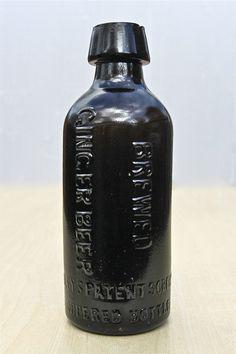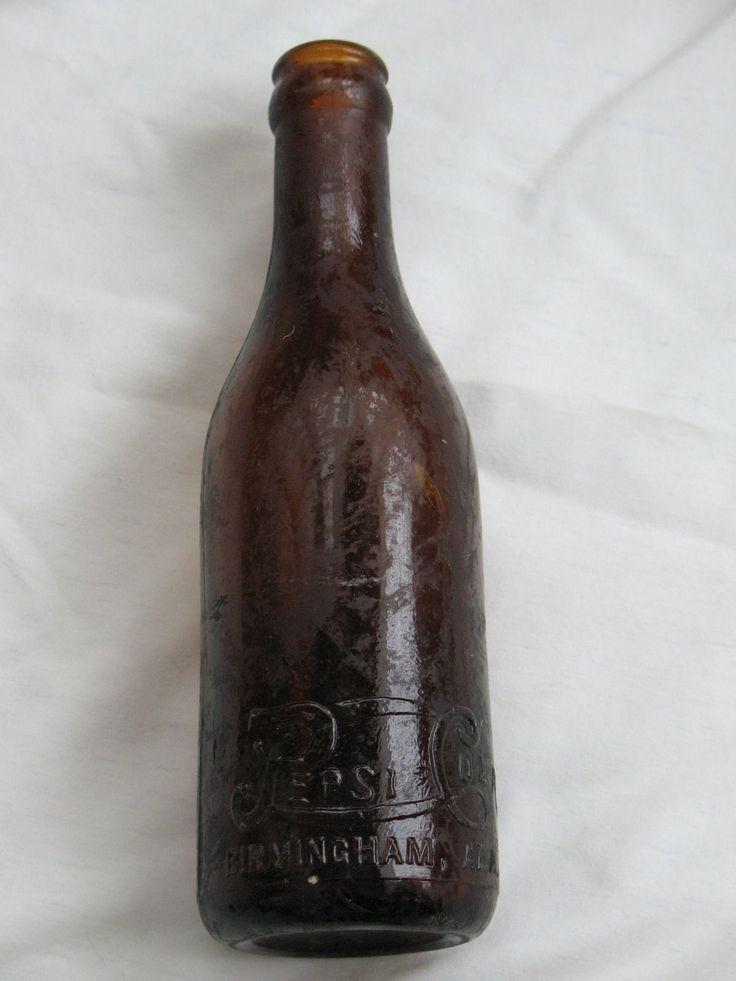The first image is the image on the left, the second image is the image on the right. For the images displayed, is the sentence "There are a total of six bottles." factually correct? Answer yes or no. No. 